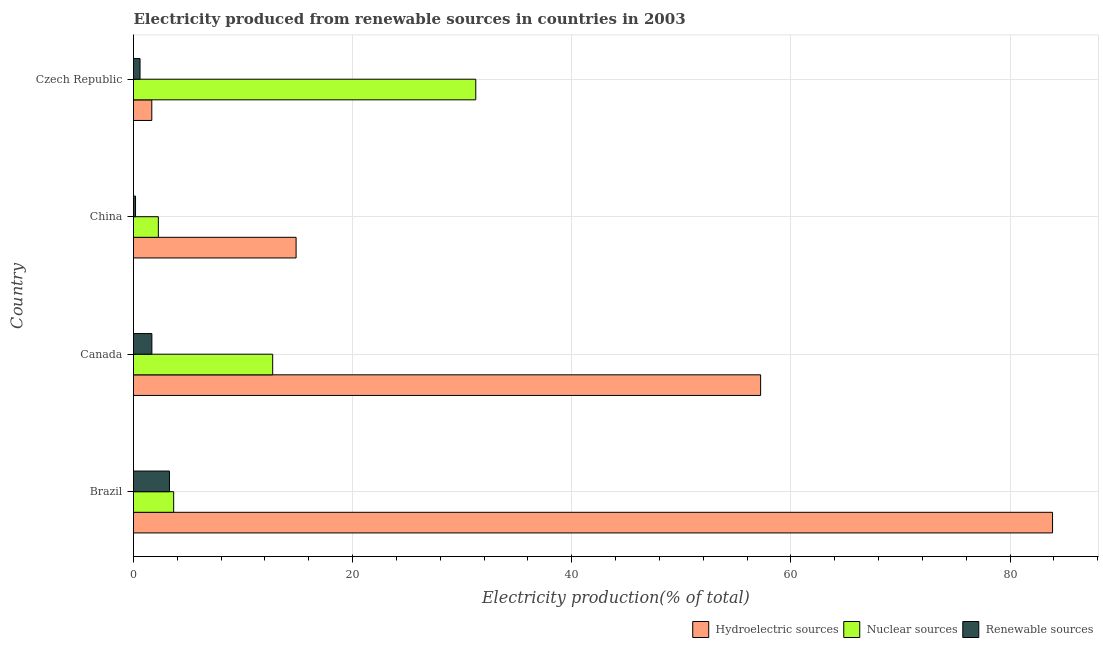How many groups of bars are there?
Your answer should be very brief. 4. Are the number of bars per tick equal to the number of legend labels?
Your response must be concise. Yes. Are the number of bars on each tick of the Y-axis equal?
Your answer should be very brief. Yes. How many bars are there on the 4th tick from the bottom?
Provide a succinct answer. 3. In how many cases, is the number of bars for a given country not equal to the number of legend labels?
Give a very brief answer. 0. What is the percentage of electricity produced by nuclear sources in Canada?
Your answer should be very brief. 12.7. Across all countries, what is the maximum percentage of electricity produced by hydroelectric sources?
Offer a very short reply. 83.88. Across all countries, what is the minimum percentage of electricity produced by nuclear sources?
Your answer should be compact. 2.27. In which country was the percentage of electricity produced by hydroelectric sources minimum?
Provide a succinct answer. Czech Republic. What is the total percentage of electricity produced by renewable sources in the graph?
Offer a very short reply. 5.74. What is the difference between the percentage of electricity produced by renewable sources in Brazil and that in Canada?
Offer a terse response. 1.6. What is the difference between the percentage of electricity produced by hydroelectric sources in Czech Republic and the percentage of electricity produced by nuclear sources in China?
Offer a very short reply. -0.6. What is the average percentage of electricity produced by hydroelectric sources per country?
Your answer should be compact. 39.41. What is the difference between the percentage of electricity produced by nuclear sources and percentage of electricity produced by renewable sources in Canada?
Ensure brevity in your answer.  11.03. In how many countries, is the percentage of electricity produced by renewable sources greater than 24 %?
Make the answer very short. 0. What is the ratio of the percentage of electricity produced by renewable sources in Brazil to that in Canada?
Give a very brief answer. 1.96. Is the percentage of electricity produced by renewable sources in Brazil less than that in Czech Republic?
Offer a very short reply. No. What is the difference between the highest and the second highest percentage of electricity produced by renewable sources?
Make the answer very short. 1.6. What is the difference between the highest and the lowest percentage of electricity produced by nuclear sources?
Keep it short and to the point. 28.97. In how many countries, is the percentage of electricity produced by nuclear sources greater than the average percentage of electricity produced by nuclear sources taken over all countries?
Keep it short and to the point. 2. Is the sum of the percentage of electricity produced by nuclear sources in Canada and China greater than the maximum percentage of electricity produced by hydroelectric sources across all countries?
Keep it short and to the point. No. What does the 3rd bar from the top in Canada represents?
Offer a terse response. Hydroelectric sources. What does the 1st bar from the bottom in Canada represents?
Provide a succinct answer. Hydroelectric sources. Are all the bars in the graph horizontal?
Ensure brevity in your answer.  Yes. How many countries are there in the graph?
Your response must be concise. 4. Are the values on the major ticks of X-axis written in scientific E-notation?
Your response must be concise. No. How are the legend labels stacked?
Offer a very short reply. Horizontal. What is the title of the graph?
Your answer should be compact. Electricity produced from renewable sources in countries in 2003. What is the label or title of the X-axis?
Give a very brief answer. Electricity production(% of total). What is the label or title of the Y-axis?
Provide a succinct answer. Country. What is the Electricity production(% of total) of Hydroelectric sources in Brazil?
Offer a very short reply. 83.88. What is the Electricity production(% of total) in Nuclear sources in Brazil?
Offer a very short reply. 3.67. What is the Electricity production(% of total) of Renewable sources in Brazil?
Provide a short and direct response. 3.28. What is the Electricity production(% of total) in Hydroelectric sources in Canada?
Make the answer very short. 57.24. What is the Electricity production(% of total) in Nuclear sources in Canada?
Your answer should be compact. 12.7. What is the Electricity production(% of total) in Renewable sources in Canada?
Ensure brevity in your answer.  1.68. What is the Electricity production(% of total) of Hydroelectric sources in China?
Give a very brief answer. 14.84. What is the Electricity production(% of total) in Nuclear sources in China?
Offer a terse response. 2.27. What is the Electricity production(% of total) in Renewable sources in China?
Your response must be concise. 0.18. What is the Electricity production(% of total) of Hydroelectric sources in Czech Republic?
Make the answer very short. 1.67. What is the Electricity production(% of total) in Nuclear sources in Czech Republic?
Your answer should be very brief. 31.24. What is the Electricity production(% of total) in Renewable sources in Czech Republic?
Offer a very short reply. 0.6. Across all countries, what is the maximum Electricity production(% of total) of Hydroelectric sources?
Your answer should be compact. 83.88. Across all countries, what is the maximum Electricity production(% of total) of Nuclear sources?
Keep it short and to the point. 31.24. Across all countries, what is the maximum Electricity production(% of total) in Renewable sources?
Keep it short and to the point. 3.28. Across all countries, what is the minimum Electricity production(% of total) of Hydroelectric sources?
Give a very brief answer. 1.67. Across all countries, what is the minimum Electricity production(% of total) of Nuclear sources?
Your answer should be compact. 2.27. Across all countries, what is the minimum Electricity production(% of total) of Renewable sources?
Ensure brevity in your answer.  0.18. What is the total Electricity production(% of total) of Hydroelectric sources in the graph?
Make the answer very short. 157.63. What is the total Electricity production(% of total) in Nuclear sources in the graph?
Your answer should be compact. 49.88. What is the total Electricity production(% of total) in Renewable sources in the graph?
Offer a terse response. 5.74. What is the difference between the Electricity production(% of total) of Hydroelectric sources in Brazil and that in Canada?
Give a very brief answer. 26.64. What is the difference between the Electricity production(% of total) of Nuclear sources in Brazil and that in Canada?
Your answer should be very brief. -9.04. What is the difference between the Electricity production(% of total) of Renewable sources in Brazil and that in Canada?
Make the answer very short. 1.6. What is the difference between the Electricity production(% of total) of Hydroelectric sources in Brazil and that in China?
Provide a short and direct response. 69.04. What is the difference between the Electricity production(% of total) of Nuclear sources in Brazil and that in China?
Your answer should be very brief. 1.4. What is the difference between the Electricity production(% of total) of Renewable sources in Brazil and that in China?
Your answer should be very brief. 3.1. What is the difference between the Electricity production(% of total) in Hydroelectric sources in Brazil and that in Czech Republic?
Offer a terse response. 82.21. What is the difference between the Electricity production(% of total) in Nuclear sources in Brazil and that in Czech Republic?
Give a very brief answer. -27.57. What is the difference between the Electricity production(% of total) in Renewable sources in Brazil and that in Czech Republic?
Your response must be concise. 2.69. What is the difference between the Electricity production(% of total) of Hydroelectric sources in Canada and that in China?
Give a very brief answer. 42.4. What is the difference between the Electricity production(% of total) of Nuclear sources in Canada and that in China?
Offer a terse response. 10.44. What is the difference between the Electricity production(% of total) of Renewable sources in Canada and that in China?
Make the answer very short. 1.49. What is the difference between the Electricity production(% of total) of Hydroelectric sources in Canada and that in Czech Republic?
Your answer should be very brief. 55.57. What is the difference between the Electricity production(% of total) of Nuclear sources in Canada and that in Czech Republic?
Provide a short and direct response. -18.54. What is the difference between the Electricity production(% of total) of Renewable sources in Canada and that in Czech Republic?
Make the answer very short. 1.08. What is the difference between the Electricity production(% of total) of Hydroelectric sources in China and that in Czech Republic?
Your answer should be compact. 13.17. What is the difference between the Electricity production(% of total) of Nuclear sources in China and that in Czech Republic?
Your answer should be very brief. -28.97. What is the difference between the Electricity production(% of total) of Renewable sources in China and that in Czech Republic?
Offer a very short reply. -0.41. What is the difference between the Electricity production(% of total) in Hydroelectric sources in Brazil and the Electricity production(% of total) in Nuclear sources in Canada?
Keep it short and to the point. 71.18. What is the difference between the Electricity production(% of total) of Hydroelectric sources in Brazil and the Electricity production(% of total) of Renewable sources in Canada?
Provide a succinct answer. 82.21. What is the difference between the Electricity production(% of total) of Nuclear sources in Brazil and the Electricity production(% of total) of Renewable sources in Canada?
Provide a succinct answer. 1.99. What is the difference between the Electricity production(% of total) of Hydroelectric sources in Brazil and the Electricity production(% of total) of Nuclear sources in China?
Your response must be concise. 81.62. What is the difference between the Electricity production(% of total) of Hydroelectric sources in Brazil and the Electricity production(% of total) of Renewable sources in China?
Your response must be concise. 83.7. What is the difference between the Electricity production(% of total) of Nuclear sources in Brazil and the Electricity production(% of total) of Renewable sources in China?
Your answer should be very brief. 3.48. What is the difference between the Electricity production(% of total) in Hydroelectric sources in Brazil and the Electricity production(% of total) in Nuclear sources in Czech Republic?
Ensure brevity in your answer.  52.64. What is the difference between the Electricity production(% of total) in Hydroelectric sources in Brazil and the Electricity production(% of total) in Renewable sources in Czech Republic?
Provide a succinct answer. 83.29. What is the difference between the Electricity production(% of total) of Nuclear sources in Brazil and the Electricity production(% of total) of Renewable sources in Czech Republic?
Your response must be concise. 3.07. What is the difference between the Electricity production(% of total) of Hydroelectric sources in Canada and the Electricity production(% of total) of Nuclear sources in China?
Make the answer very short. 54.97. What is the difference between the Electricity production(% of total) of Hydroelectric sources in Canada and the Electricity production(% of total) of Renewable sources in China?
Give a very brief answer. 57.05. What is the difference between the Electricity production(% of total) of Nuclear sources in Canada and the Electricity production(% of total) of Renewable sources in China?
Your response must be concise. 12.52. What is the difference between the Electricity production(% of total) in Hydroelectric sources in Canada and the Electricity production(% of total) in Nuclear sources in Czech Republic?
Your answer should be compact. 26. What is the difference between the Electricity production(% of total) of Hydroelectric sources in Canada and the Electricity production(% of total) of Renewable sources in Czech Republic?
Make the answer very short. 56.64. What is the difference between the Electricity production(% of total) in Nuclear sources in Canada and the Electricity production(% of total) in Renewable sources in Czech Republic?
Offer a terse response. 12.11. What is the difference between the Electricity production(% of total) of Hydroelectric sources in China and the Electricity production(% of total) of Nuclear sources in Czech Republic?
Your answer should be very brief. -16.4. What is the difference between the Electricity production(% of total) of Hydroelectric sources in China and the Electricity production(% of total) of Renewable sources in Czech Republic?
Your response must be concise. 14.24. What is the difference between the Electricity production(% of total) in Nuclear sources in China and the Electricity production(% of total) in Renewable sources in Czech Republic?
Provide a succinct answer. 1.67. What is the average Electricity production(% of total) in Hydroelectric sources per country?
Provide a short and direct response. 39.41. What is the average Electricity production(% of total) of Nuclear sources per country?
Offer a very short reply. 12.47. What is the average Electricity production(% of total) of Renewable sources per country?
Offer a very short reply. 1.43. What is the difference between the Electricity production(% of total) of Hydroelectric sources and Electricity production(% of total) of Nuclear sources in Brazil?
Provide a succinct answer. 80.22. What is the difference between the Electricity production(% of total) of Hydroelectric sources and Electricity production(% of total) of Renewable sources in Brazil?
Keep it short and to the point. 80.6. What is the difference between the Electricity production(% of total) of Nuclear sources and Electricity production(% of total) of Renewable sources in Brazil?
Offer a very short reply. 0.39. What is the difference between the Electricity production(% of total) in Hydroelectric sources and Electricity production(% of total) in Nuclear sources in Canada?
Make the answer very short. 44.54. What is the difference between the Electricity production(% of total) in Hydroelectric sources and Electricity production(% of total) in Renewable sources in Canada?
Your answer should be very brief. 55.56. What is the difference between the Electricity production(% of total) of Nuclear sources and Electricity production(% of total) of Renewable sources in Canada?
Provide a short and direct response. 11.03. What is the difference between the Electricity production(% of total) in Hydroelectric sources and Electricity production(% of total) in Nuclear sources in China?
Your answer should be compact. 12.57. What is the difference between the Electricity production(% of total) of Hydroelectric sources and Electricity production(% of total) of Renewable sources in China?
Keep it short and to the point. 14.65. What is the difference between the Electricity production(% of total) of Nuclear sources and Electricity production(% of total) of Renewable sources in China?
Your answer should be compact. 2.08. What is the difference between the Electricity production(% of total) in Hydroelectric sources and Electricity production(% of total) in Nuclear sources in Czech Republic?
Offer a terse response. -29.57. What is the difference between the Electricity production(% of total) of Hydroelectric sources and Electricity production(% of total) of Renewable sources in Czech Republic?
Ensure brevity in your answer.  1.07. What is the difference between the Electricity production(% of total) of Nuclear sources and Electricity production(% of total) of Renewable sources in Czech Republic?
Ensure brevity in your answer.  30.64. What is the ratio of the Electricity production(% of total) of Hydroelectric sources in Brazil to that in Canada?
Offer a terse response. 1.47. What is the ratio of the Electricity production(% of total) of Nuclear sources in Brazil to that in Canada?
Keep it short and to the point. 0.29. What is the ratio of the Electricity production(% of total) in Renewable sources in Brazil to that in Canada?
Provide a succinct answer. 1.96. What is the ratio of the Electricity production(% of total) in Hydroelectric sources in Brazil to that in China?
Offer a very short reply. 5.65. What is the ratio of the Electricity production(% of total) in Nuclear sources in Brazil to that in China?
Offer a very short reply. 1.62. What is the ratio of the Electricity production(% of total) of Renewable sources in Brazil to that in China?
Your answer should be compact. 17.8. What is the ratio of the Electricity production(% of total) in Hydroelectric sources in Brazil to that in Czech Republic?
Provide a short and direct response. 50.23. What is the ratio of the Electricity production(% of total) of Nuclear sources in Brazil to that in Czech Republic?
Offer a terse response. 0.12. What is the ratio of the Electricity production(% of total) of Renewable sources in Brazil to that in Czech Republic?
Your response must be concise. 5.51. What is the ratio of the Electricity production(% of total) of Hydroelectric sources in Canada to that in China?
Provide a succinct answer. 3.86. What is the ratio of the Electricity production(% of total) of Nuclear sources in Canada to that in China?
Give a very brief answer. 5.6. What is the ratio of the Electricity production(% of total) of Renewable sources in Canada to that in China?
Provide a succinct answer. 9.1. What is the ratio of the Electricity production(% of total) in Hydroelectric sources in Canada to that in Czech Republic?
Offer a very short reply. 34.28. What is the ratio of the Electricity production(% of total) in Nuclear sources in Canada to that in Czech Republic?
Offer a very short reply. 0.41. What is the ratio of the Electricity production(% of total) in Renewable sources in Canada to that in Czech Republic?
Your answer should be compact. 2.82. What is the ratio of the Electricity production(% of total) of Hydroelectric sources in China to that in Czech Republic?
Your answer should be very brief. 8.89. What is the ratio of the Electricity production(% of total) in Nuclear sources in China to that in Czech Republic?
Make the answer very short. 0.07. What is the ratio of the Electricity production(% of total) of Renewable sources in China to that in Czech Republic?
Give a very brief answer. 0.31. What is the difference between the highest and the second highest Electricity production(% of total) of Hydroelectric sources?
Make the answer very short. 26.64. What is the difference between the highest and the second highest Electricity production(% of total) of Nuclear sources?
Provide a short and direct response. 18.54. What is the difference between the highest and the second highest Electricity production(% of total) of Renewable sources?
Provide a short and direct response. 1.6. What is the difference between the highest and the lowest Electricity production(% of total) of Hydroelectric sources?
Provide a succinct answer. 82.21. What is the difference between the highest and the lowest Electricity production(% of total) in Nuclear sources?
Your response must be concise. 28.97. What is the difference between the highest and the lowest Electricity production(% of total) in Renewable sources?
Provide a short and direct response. 3.1. 